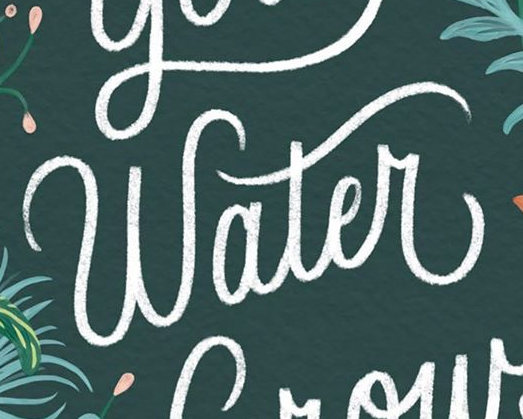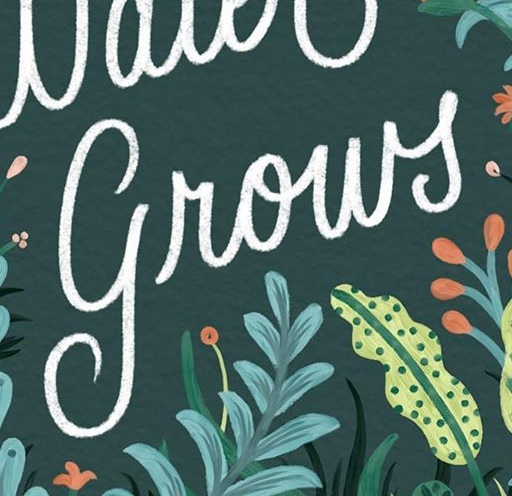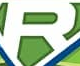Read the text content from these images in order, separated by a semicolon. Water; grows; R 